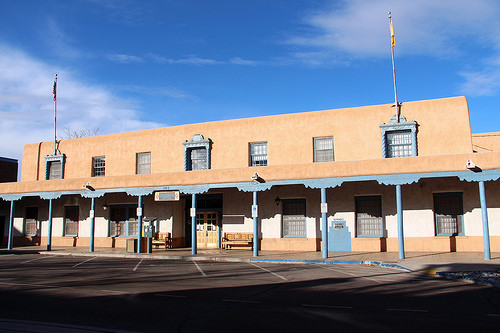<image>
Is there a window above the pillar? No. The window is not positioned above the pillar. The vertical arrangement shows a different relationship. 